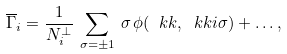Convert formula to latex. <formula><loc_0><loc_0><loc_500><loc_500>\overline { \Gamma } _ { i } = \frac { 1 } { N ^ { \perp } _ { i } } \, \sum _ { \sigma = \pm 1 } \, \sigma \, \phi ( \ k k , \ k k i \sigma ) + \dots ,</formula> 